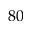<formula> <loc_0><loc_0><loc_500><loc_500>8 0</formula> 